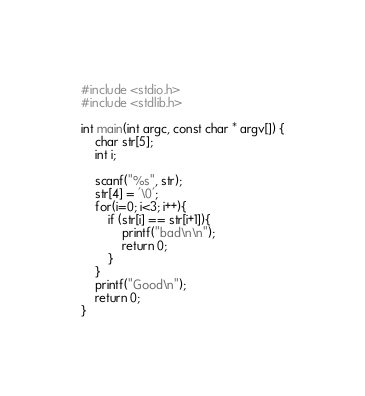Convert code to text. <code><loc_0><loc_0><loc_500><loc_500><_C_>#include <stdio.h>
#include <stdlib.h>

int main(int argc, const char * argv[]) {
    char str[5];
    int i;
    
    scanf("%s", str);
    str[4] = '\0';
    for(i=0; i<3; i++){
        if (str[i] == str[i+1]){
            printf("bad\n\n");
            return 0;
        }
    }
    printf("Good\n");
    return 0;
}
</code> 